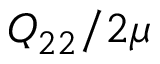Convert formula to latex. <formula><loc_0><loc_0><loc_500><loc_500>Q _ { 2 2 } / 2 \mu</formula> 